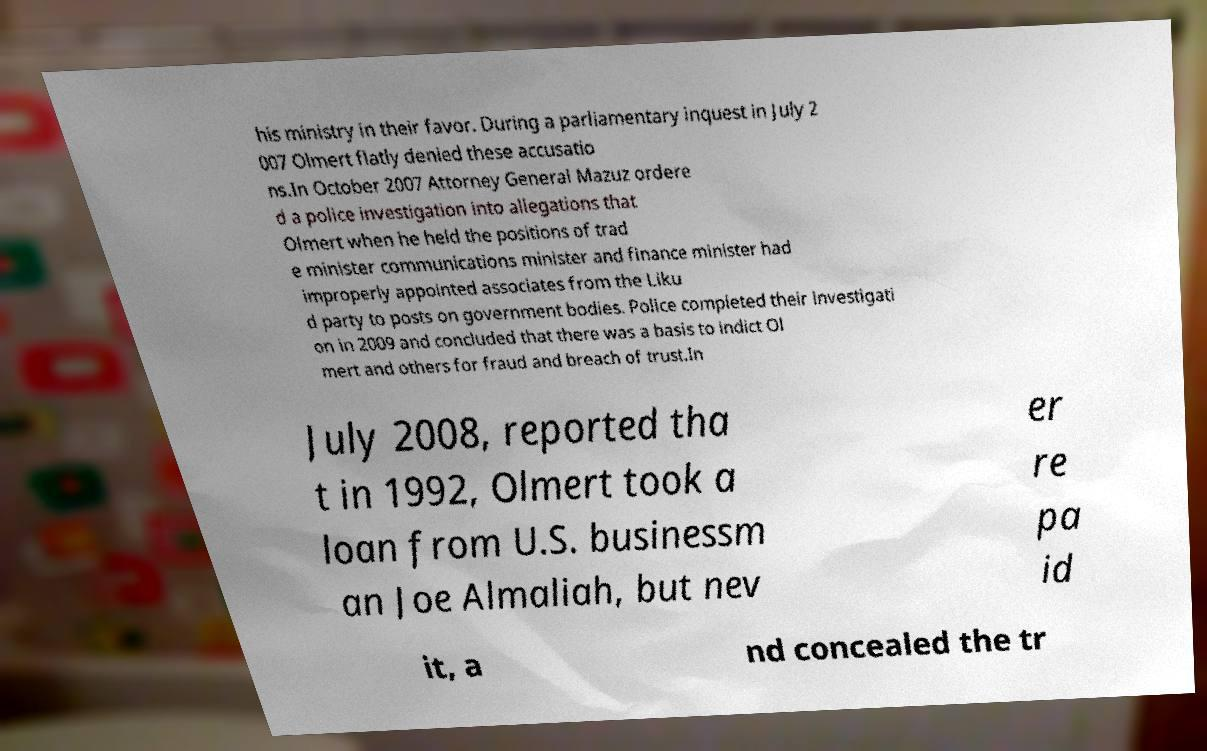I need the written content from this picture converted into text. Can you do that? his ministry in their favor. During a parliamentary inquest in July 2 007 Olmert flatly denied these accusatio ns.In October 2007 Attorney General Mazuz ordere d a police investigation into allegations that Olmert when he held the positions of trad e minister communications minister and finance minister had improperly appointed associates from the Liku d party to posts on government bodies. Police completed their investigati on in 2009 and concluded that there was a basis to indict Ol mert and others for fraud and breach of trust.In July 2008, reported tha t in 1992, Olmert took a loan from U.S. businessm an Joe Almaliah, but nev er re pa id it, a nd concealed the tr 